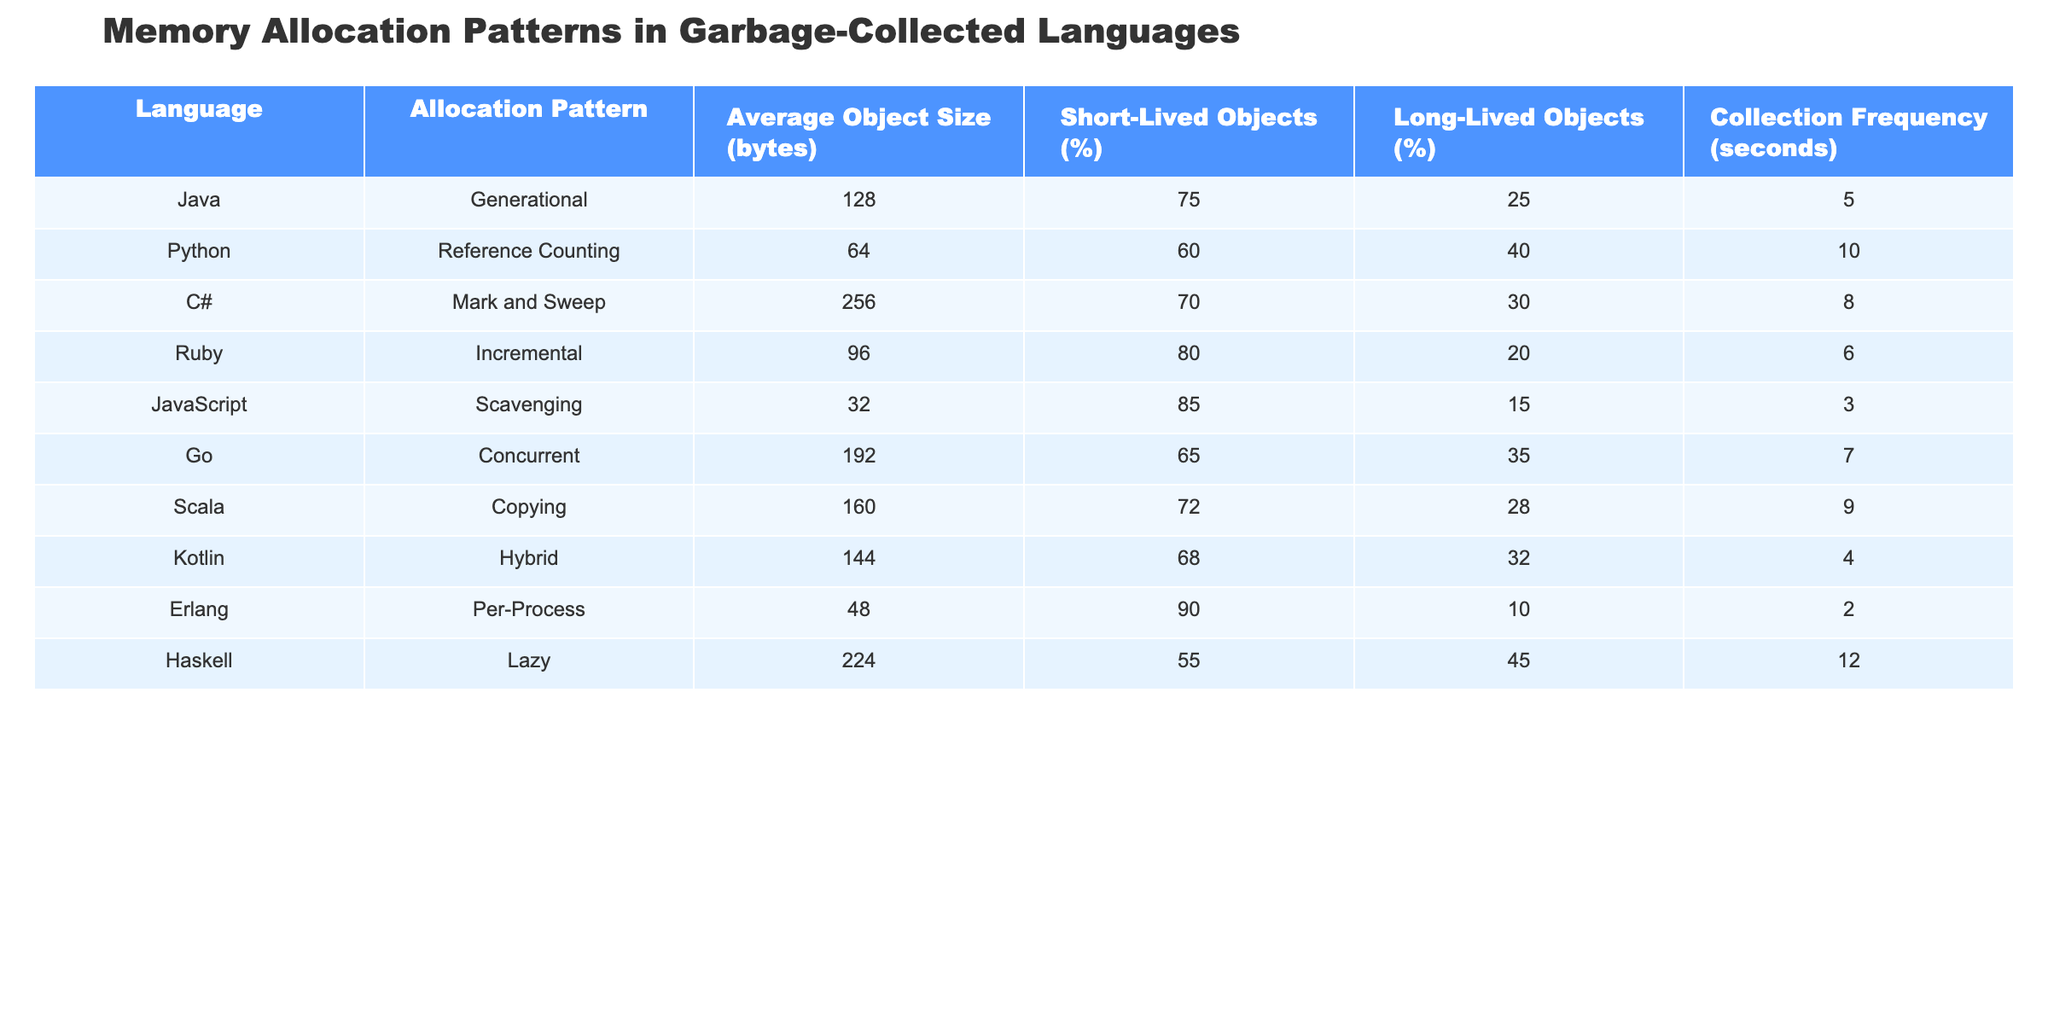What is the average object size for Python? The "Average Object Size (bytes)" for Python is listed as 64 in the table.
Answer: 64 Which language has the highest percentage of short-lived objects? The table shows that Erlang has the highest percentage of short-lived objects at 90%.
Answer: 90% How often do objects get collected in Java? The "Collection Frequency (seconds)" for Java is 5 seconds, as noted in the table.
Answer: 5 seconds What is the allocation pattern used by C#? The allocation pattern listed for C# is "Mark and Sweep," as shown in the table.
Answer: Mark and Sweep Which language has the lowest average object size? JavaScript has the lowest average object size at 32 bytes, according to the table.
Answer: 32 bytes If we calculate the average collection frequency across all languages, what do we get? Adding the collection frequencies: 5 + 10 + 8 + 6 + 3 + 7 + 9 + 4 + 2 + 12 = 66. There are 10 languages, so the average is 66/10 = 6.6 seconds.
Answer: 6.6 seconds Is it true that all languages have more than 50% short-lived objects? Based on the table, Python and Haskell have 60% and 55% short-lived objects respectively, which means not all languages exceed 50%.
Answer: No What is the difference in average object size between Ruby and Go? Ruby has an average object size of 96 bytes, while Go has an average size of 192 bytes. The difference is 192 - 96 = 96 bytes.
Answer: 96 bytes Which language's collection frequency is closest to the average of 6 seconds for the languages listed? The collection frequency for Kotlin is 4 seconds, which is the closest to the average of 6 seconds among the lower frequencies.
Answer: 4 seconds If we consider the long-lived objects percentage, which language has the smallest percentage? The table lists that Erlang has the smallest percentage of long-lived objects at 10%.
Answer: 10% 